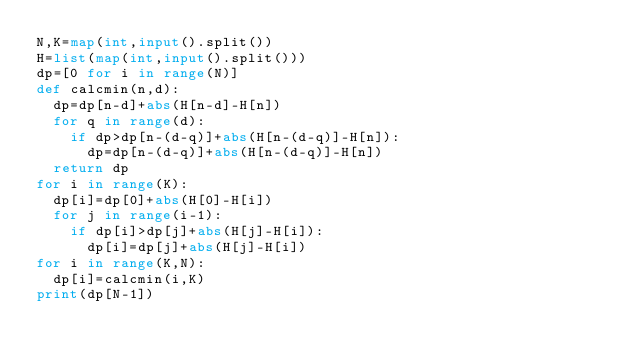Convert code to text. <code><loc_0><loc_0><loc_500><loc_500><_Python_>N,K=map(int,input().split())
H=list(map(int,input().split()))
dp=[0 for i in range(N)]
def calcmin(n,d):
  dp=dp[n-d]+abs(H[n-d]-H[n])
  for q in range(d):
    if dp>dp[n-(d-q)]+abs(H[n-(d-q)]-H[n]):
      dp=dp[n-(d-q)]+abs(H[n-(d-q)]-H[n])
  return dp
for i in range(K):
  dp[i]=dp[0]+abs(H[0]-H[i])
  for j in range(i-1):
    if dp[i]>dp[j]+abs(H[j]-H[i]):
      dp[i]=dp[j]+abs(H[j]-H[i])
for i in range(K,N):
  dp[i]=calcmin(i,K)
print(dp[N-1])</code> 